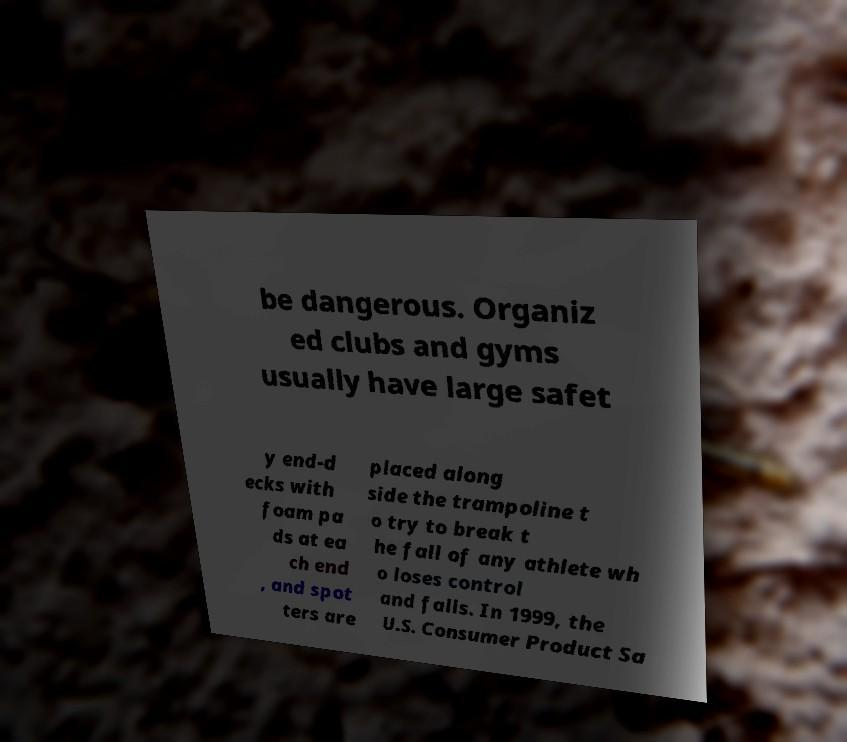There's text embedded in this image that I need extracted. Can you transcribe it verbatim? be dangerous. Organiz ed clubs and gyms usually have large safet y end-d ecks with foam pa ds at ea ch end , and spot ters are placed along side the trampoline t o try to break t he fall of any athlete wh o loses control and falls. In 1999, the U.S. Consumer Product Sa 